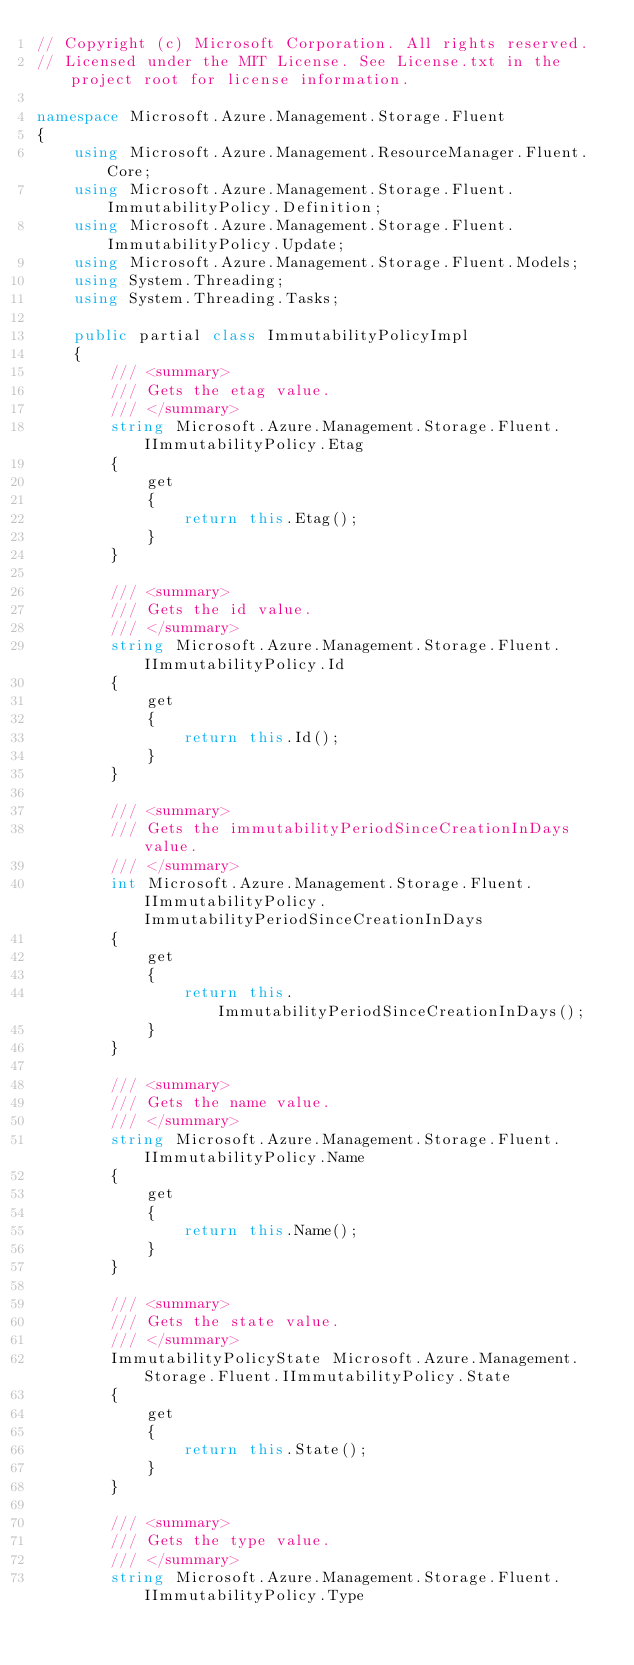Convert code to text. <code><loc_0><loc_0><loc_500><loc_500><_C#_>// Copyright (c) Microsoft Corporation. All rights reserved.
// Licensed under the MIT License. See License.txt in the project root for license information.

namespace Microsoft.Azure.Management.Storage.Fluent
{
    using Microsoft.Azure.Management.ResourceManager.Fluent.Core;
    using Microsoft.Azure.Management.Storage.Fluent.ImmutabilityPolicy.Definition;
    using Microsoft.Azure.Management.Storage.Fluent.ImmutabilityPolicy.Update;
    using Microsoft.Azure.Management.Storage.Fluent.Models;
    using System.Threading;
    using System.Threading.Tasks;

    public partial class ImmutabilityPolicyImpl 
    {
        /// <summary>
        /// Gets the etag value.
        /// </summary>
        string Microsoft.Azure.Management.Storage.Fluent.IImmutabilityPolicy.Etag
        {
            get
            {
                return this.Etag();
            }
        }

        /// <summary>
        /// Gets the id value.
        /// </summary>
        string Microsoft.Azure.Management.Storage.Fluent.IImmutabilityPolicy.Id
        {
            get
            {
                return this.Id();
            }
        }

        /// <summary>
        /// Gets the immutabilityPeriodSinceCreationInDays value.
        /// </summary>
        int Microsoft.Azure.Management.Storage.Fluent.IImmutabilityPolicy.ImmutabilityPeriodSinceCreationInDays
        {
            get
            {
                return this.ImmutabilityPeriodSinceCreationInDays();
            }
        }

        /// <summary>
        /// Gets the name value.
        /// </summary>
        string Microsoft.Azure.Management.Storage.Fluent.IImmutabilityPolicy.Name
        {
            get
            {
                return this.Name();
            }
        }

        /// <summary>
        /// Gets the state value.
        /// </summary>
        ImmutabilityPolicyState Microsoft.Azure.Management.Storage.Fluent.IImmutabilityPolicy.State
        {
            get
            {
                return this.State();
            }
        }

        /// <summary>
        /// Gets the type value.
        /// </summary>
        string Microsoft.Azure.Management.Storage.Fluent.IImmutabilityPolicy.Type</code> 